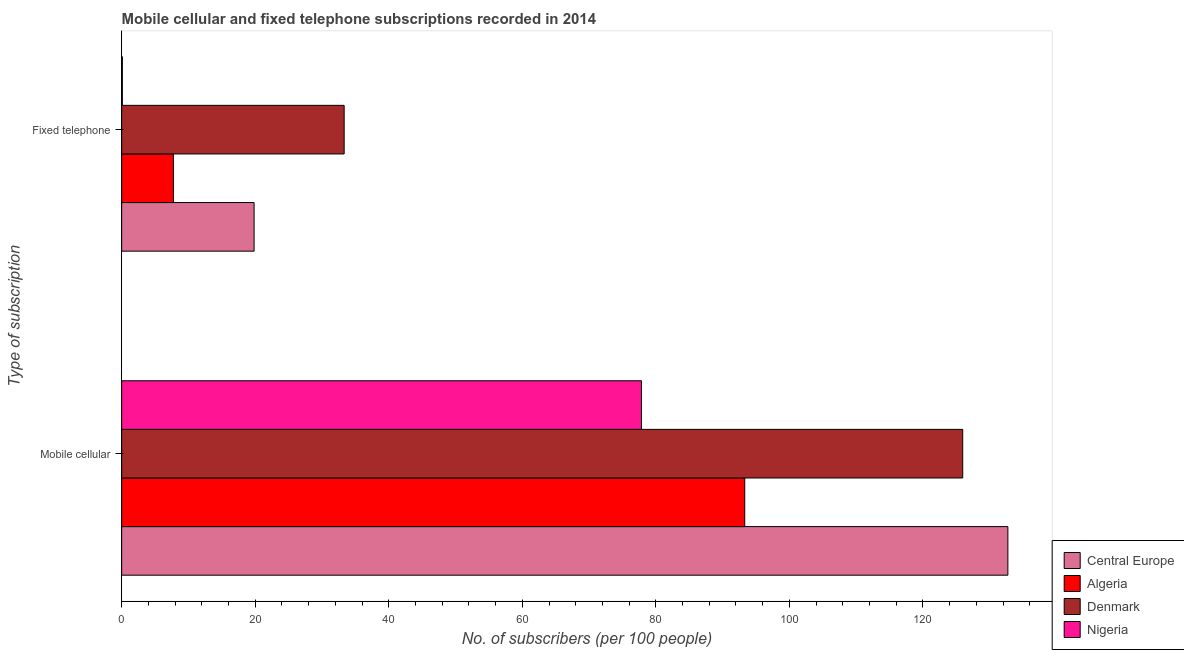How many different coloured bars are there?
Give a very brief answer. 4. How many bars are there on the 1st tick from the bottom?
Give a very brief answer. 4. What is the label of the 1st group of bars from the top?
Ensure brevity in your answer.  Fixed telephone. What is the number of mobile cellular subscribers in Algeria?
Keep it short and to the point. 93.31. Across all countries, what is the maximum number of fixed telephone subscribers?
Make the answer very short. 33.32. Across all countries, what is the minimum number of fixed telephone subscribers?
Provide a short and direct response. 0.1. In which country was the number of fixed telephone subscribers maximum?
Ensure brevity in your answer.  Denmark. In which country was the number of fixed telephone subscribers minimum?
Your answer should be compact. Nigeria. What is the total number of fixed telephone subscribers in the graph?
Your answer should be compact. 61. What is the difference between the number of fixed telephone subscribers in Nigeria and that in Algeria?
Give a very brief answer. -7.64. What is the difference between the number of fixed telephone subscribers in Denmark and the number of mobile cellular subscribers in Nigeria?
Provide a succinct answer. -44.52. What is the average number of mobile cellular subscribers per country?
Make the answer very short. 107.46. What is the difference between the number of fixed telephone subscribers and number of mobile cellular subscribers in Nigeria?
Keep it short and to the point. -77.74. In how many countries, is the number of mobile cellular subscribers greater than 108 ?
Provide a succinct answer. 2. What is the ratio of the number of fixed telephone subscribers in Nigeria to that in Algeria?
Ensure brevity in your answer.  0.01. In how many countries, is the number of mobile cellular subscribers greater than the average number of mobile cellular subscribers taken over all countries?
Keep it short and to the point. 2. What does the 2nd bar from the top in Fixed telephone represents?
Your answer should be very brief. Denmark. What does the 1st bar from the bottom in Mobile cellular represents?
Offer a very short reply. Central Europe. How many bars are there?
Provide a short and direct response. 8. What is the difference between two consecutive major ticks on the X-axis?
Offer a very short reply. 20. Are the values on the major ticks of X-axis written in scientific E-notation?
Keep it short and to the point. No. Does the graph contain any zero values?
Ensure brevity in your answer.  No. Does the graph contain grids?
Your answer should be very brief. No. How many legend labels are there?
Offer a terse response. 4. What is the title of the graph?
Give a very brief answer. Mobile cellular and fixed telephone subscriptions recorded in 2014. What is the label or title of the X-axis?
Give a very brief answer. No. of subscribers (per 100 people). What is the label or title of the Y-axis?
Your answer should be compact. Type of subscription. What is the No. of subscribers (per 100 people) in Central Europe in Mobile cellular?
Provide a short and direct response. 132.72. What is the No. of subscribers (per 100 people) of Algeria in Mobile cellular?
Your response must be concise. 93.31. What is the No. of subscribers (per 100 people) of Denmark in Mobile cellular?
Provide a succinct answer. 125.96. What is the No. of subscribers (per 100 people) of Nigeria in Mobile cellular?
Your response must be concise. 77.84. What is the No. of subscribers (per 100 people) in Central Europe in Fixed telephone?
Offer a very short reply. 19.83. What is the No. of subscribers (per 100 people) in Algeria in Fixed telephone?
Keep it short and to the point. 7.75. What is the No. of subscribers (per 100 people) of Denmark in Fixed telephone?
Make the answer very short. 33.32. What is the No. of subscribers (per 100 people) of Nigeria in Fixed telephone?
Your answer should be very brief. 0.1. Across all Type of subscription, what is the maximum No. of subscribers (per 100 people) in Central Europe?
Provide a succinct answer. 132.72. Across all Type of subscription, what is the maximum No. of subscribers (per 100 people) in Algeria?
Your response must be concise. 93.31. Across all Type of subscription, what is the maximum No. of subscribers (per 100 people) in Denmark?
Your answer should be very brief. 125.96. Across all Type of subscription, what is the maximum No. of subscribers (per 100 people) in Nigeria?
Your answer should be compact. 77.84. Across all Type of subscription, what is the minimum No. of subscribers (per 100 people) of Central Europe?
Ensure brevity in your answer.  19.83. Across all Type of subscription, what is the minimum No. of subscribers (per 100 people) of Algeria?
Give a very brief answer. 7.75. Across all Type of subscription, what is the minimum No. of subscribers (per 100 people) of Denmark?
Your answer should be very brief. 33.32. Across all Type of subscription, what is the minimum No. of subscribers (per 100 people) in Nigeria?
Provide a succinct answer. 0.1. What is the total No. of subscribers (per 100 people) in Central Europe in the graph?
Your answer should be compact. 152.55. What is the total No. of subscribers (per 100 people) of Algeria in the graph?
Make the answer very short. 101.06. What is the total No. of subscribers (per 100 people) in Denmark in the graph?
Your response must be concise. 159.28. What is the total No. of subscribers (per 100 people) in Nigeria in the graph?
Provide a succinct answer. 77.94. What is the difference between the No. of subscribers (per 100 people) of Central Europe in Mobile cellular and that in Fixed telephone?
Your answer should be very brief. 112.89. What is the difference between the No. of subscribers (per 100 people) of Algeria in Mobile cellular and that in Fixed telephone?
Your answer should be very brief. 85.57. What is the difference between the No. of subscribers (per 100 people) in Denmark in Mobile cellular and that in Fixed telephone?
Your answer should be compact. 92.64. What is the difference between the No. of subscribers (per 100 people) of Nigeria in Mobile cellular and that in Fixed telephone?
Ensure brevity in your answer.  77.74. What is the difference between the No. of subscribers (per 100 people) in Central Europe in Mobile cellular and the No. of subscribers (per 100 people) in Algeria in Fixed telephone?
Offer a terse response. 124.97. What is the difference between the No. of subscribers (per 100 people) of Central Europe in Mobile cellular and the No. of subscribers (per 100 people) of Denmark in Fixed telephone?
Give a very brief answer. 99.4. What is the difference between the No. of subscribers (per 100 people) in Central Europe in Mobile cellular and the No. of subscribers (per 100 people) in Nigeria in Fixed telephone?
Keep it short and to the point. 132.62. What is the difference between the No. of subscribers (per 100 people) of Algeria in Mobile cellular and the No. of subscribers (per 100 people) of Denmark in Fixed telephone?
Give a very brief answer. 59.99. What is the difference between the No. of subscribers (per 100 people) in Algeria in Mobile cellular and the No. of subscribers (per 100 people) in Nigeria in Fixed telephone?
Offer a very short reply. 93.21. What is the difference between the No. of subscribers (per 100 people) in Denmark in Mobile cellular and the No. of subscribers (per 100 people) in Nigeria in Fixed telephone?
Make the answer very short. 125.86. What is the average No. of subscribers (per 100 people) of Central Europe per Type of subscription?
Make the answer very short. 76.28. What is the average No. of subscribers (per 100 people) of Algeria per Type of subscription?
Keep it short and to the point. 50.53. What is the average No. of subscribers (per 100 people) of Denmark per Type of subscription?
Your response must be concise. 79.64. What is the average No. of subscribers (per 100 people) in Nigeria per Type of subscription?
Your answer should be compact. 38.97. What is the difference between the No. of subscribers (per 100 people) in Central Europe and No. of subscribers (per 100 people) in Algeria in Mobile cellular?
Your response must be concise. 39.41. What is the difference between the No. of subscribers (per 100 people) in Central Europe and No. of subscribers (per 100 people) in Denmark in Mobile cellular?
Offer a terse response. 6.76. What is the difference between the No. of subscribers (per 100 people) of Central Europe and No. of subscribers (per 100 people) of Nigeria in Mobile cellular?
Provide a succinct answer. 54.88. What is the difference between the No. of subscribers (per 100 people) of Algeria and No. of subscribers (per 100 people) of Denmark in Mobile cellular?
Your answer should be very brief. -32.65. What is the difference between the No. of subscribers (per 100 people) of Algeria and No. of subscribers (per 100 people) of Nigeria in Mobile cellular?
Ensure brevity in your answer.  15.47. What is the difference between the No. of subscribers (per 100 people) in Denmark and No. of subscribers (per 100 people) in Nigeria in Mobile cellular?
Your answer should be compact. 48.12. What is the difference between the No. of subscribers (per 100 people) in Central Europe and No. of subscribers (per 100 people) in Algeria in Fixed telephone?
Ensure brevity in your answer.  12.09. What is the difference between the No. of subscribers (per 100 people) in Central Europe and No. of subscribers (per 100 people) in Denmark in Fixed telephone?
Ensure brevity in your answer.  -13.49. What is the difference between the No. of subscribers (per 100 people) of Central Europe and No. of subscribers (per 100 people) of Nigeria in Fixed telephone?
Give a very brief answer. 19.73. What is the difference between the No. of subscribers (per 100 people) in Algeria and No. of subscribers (per 100 people) in Denmark in Fixed telephone?
Offer a very short reply. -25.57. What is the difference between the No. of subscribers (per 100 people) in Algeria and No. of subscribers (per 100 people) in Nigeria in Fixed telephone?
Your answer should be very brief. 7.64. What is the difference between the No. of subscribers (per 100 people) of Denmark and No. of subscribers (per 100 people) of Nigeria in Fixed telephone?
Make the answer very short. 33.22. What is the ratio of the No. of subscribers (per 100 people) of Central Europe in Mobile cellular to that in Fixed telephone?
Your answer should be compact. 6.69. What is the ratio of the No. of subscribers (per 100 people) in Algeria in Mobile cellular to that in Fixed telephone?
Offer a very short reply. 12.05. What is the ratio of the No. of subscribers (per 100 people) in Denmark in Mobile cellular to that in Fixed telephone?
Ensure brevity in your answer.  3.78. What is the ratio of the No. of subscribers (per 100 people) of Nigeria in Mobile cellular to that in Fixed telephone?
Ensure brevity in your answer.  758.14. What is the difference between the highest and the second highest No. of subscribers (per 100 people) of Central Europe?
Give a very brief answer. 112.89. What is the difference between the highest and the second highest No. of subscribers (per 100 people) of Algeria?
Ensure brevity in your answer.  85.57. What is the difference between the highest and the second highest No. of subscribers (per 100 people) in Denmark?
Offer a terse response. 92.64. What is the difference between the highest and the second highest No. of subscribers (per 100 people) in Nigeria?
Offer a very short reply. 77.74. What is the difference between the highest and the lowest No. of subscribers (per 100 people) in Central Europe?
Offer a terse response. 112.89. What is the difference between the highest and the lowest No. of subscribers (per 100 people) of Algeria?
Offer a very short reply. 85.57. What is the difference between the highest and the lowest No. of subscribers (per 100 people) in Denmark?
Make the answer very short. 92.64. What is the difference between the highest and the lowest No. of subscribers (per 100 people) in Nigeria?
Provide a succinct answer. 77.74. 